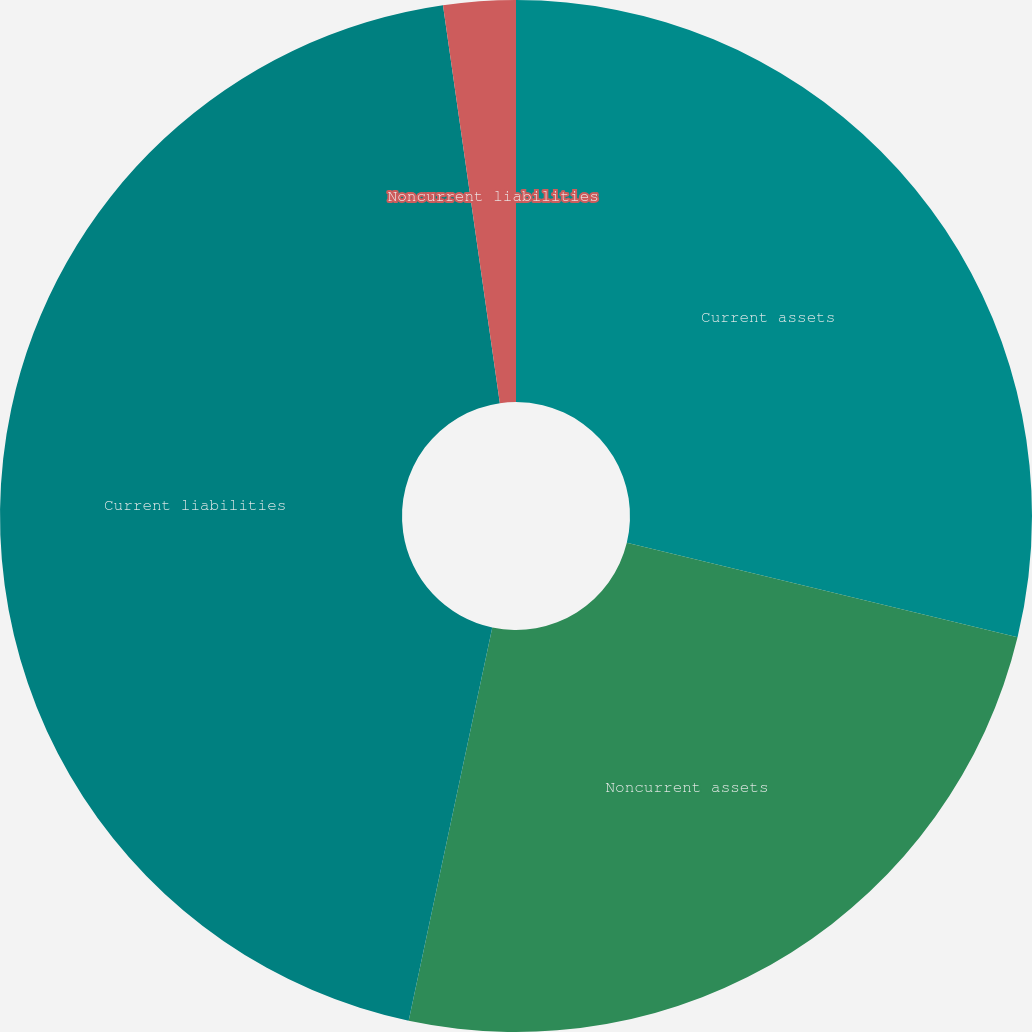Convert chart to OTSL. <chart><loc_0><loc_0><loc_500><loc_500><pie_chart><fcel>Current assets<fcel>Noncurrent assets<fcel>Current liabilities<fcel>Noncurrent liabilities<nl><fcel>28.78%<fcel>24.56%<fcel>44.41%<fcel>2.26%<nl></chart> 